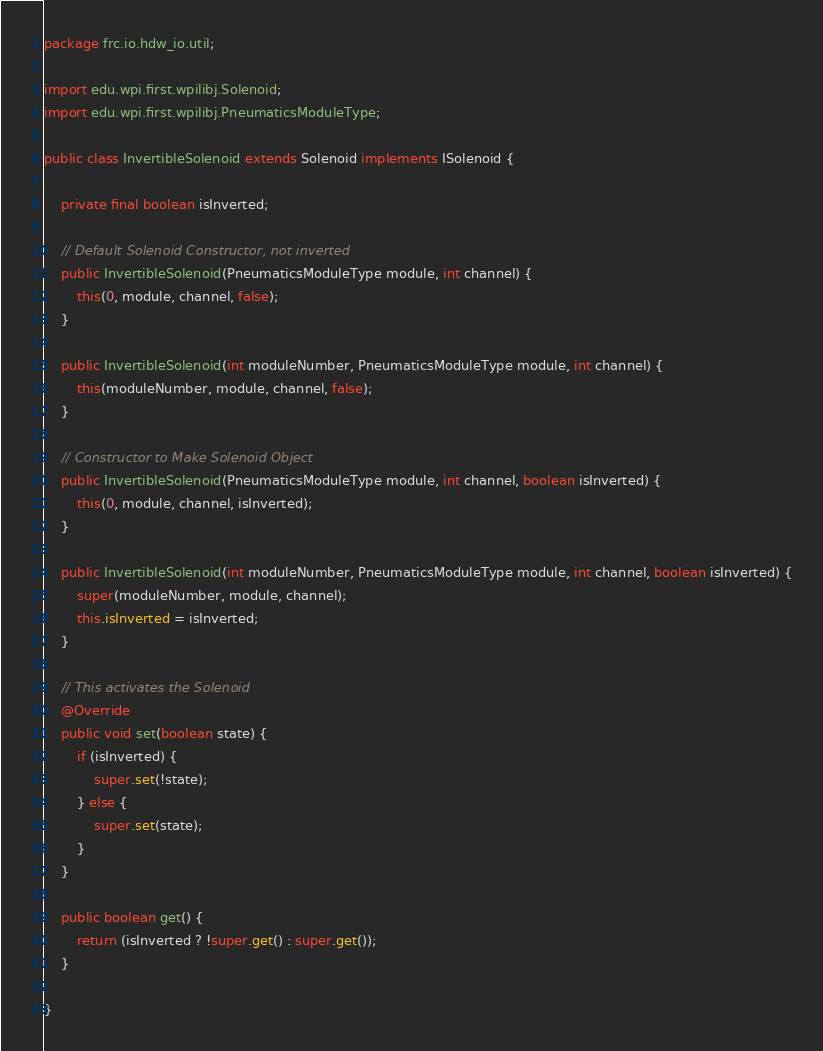Convert code to text. <code><loc_0><loc_0><loc_500><loc_500><_Java_>package frc.io.hdw_io.util;

import edu.wpi.first.wpilibj.Solenoid;
import edu.wpi.first.wpilibj.PneumaticsModuleType;

public class InvertibleSolenoid extends Solenoid implements ISolenoid {

    private final boolean isInverted;

    // Default Solenoid Constructor, not inverted
    public InvertibleSolenoid(PneumaticsModuleType module, int channel) {
        this(0, module, channel, false);
    }

    public InvertibleSolenoid(int moduleNumber, PneumaticsModuleType module, int channel) {
        this(moduleNumber, module, channel, false);
    }

    // Constructor to Make Solenoid Object
    public InvertibleSolenoid(PneumaticsModuleType module, int channel, boolean isInverted) {
        this(0, module, channel, isInverted);
    }

    public InvertibleSolenoid(int moduleNumber, PneumaticsModuleType module, int channel, boolean isInverted) {
        super(moduleNumber, module, channel);
        this.isInverted = isInverted;
    }

    // This activates the Solenoid
    @Override
    public void set(boolean state) {
        if (isInverted) {
            super.set(!state);
        } else {
            super.set(state);
        }
    }

    public boolean get() {
        return (isInverted ? !super.get() : super.get());
    }

}</code> 